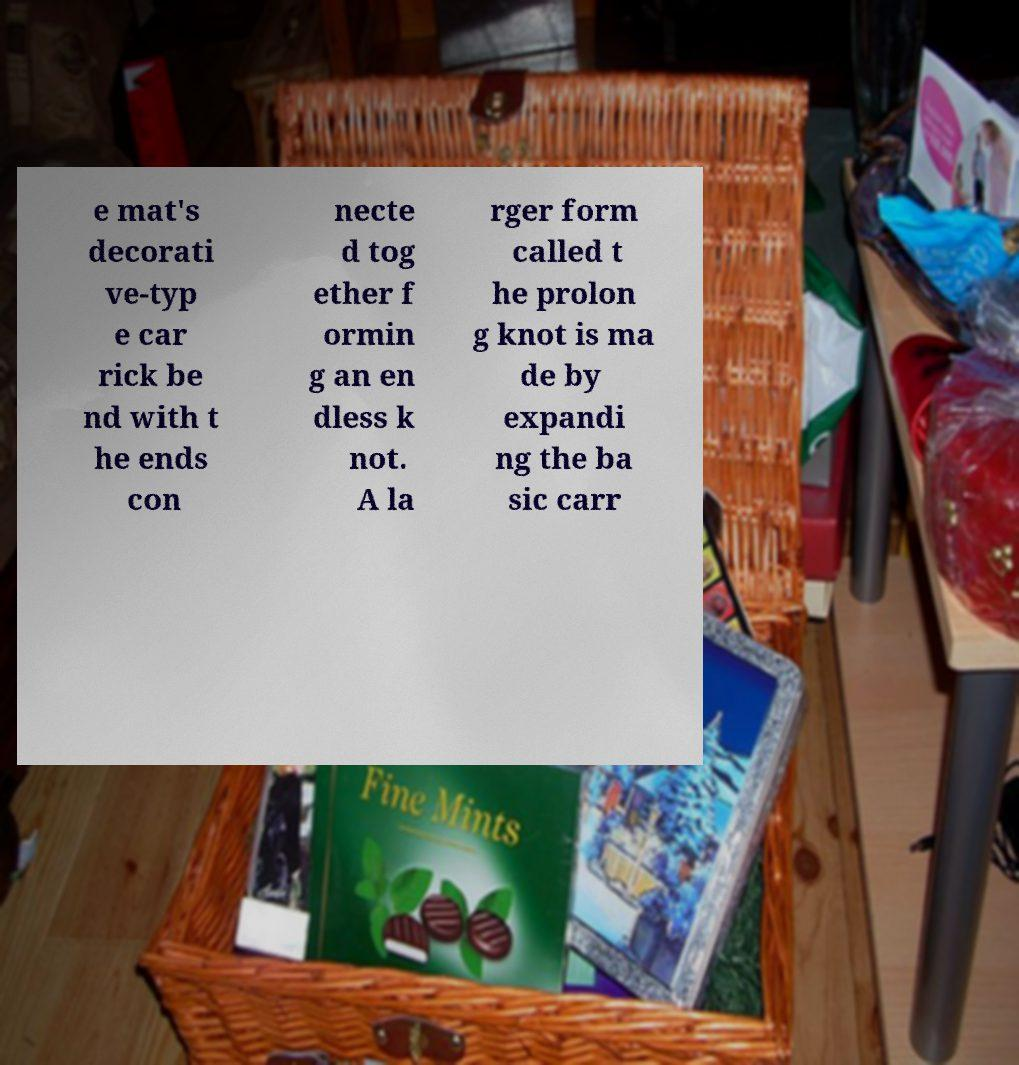I need the written content from this picture converted into text. Can you do that? e mat's decorati ve-typ e car rick be nd with t he ends con necte d tog ether f ormin g an en dless k not. A la rger form called t he prolon g knot is ma de by expandi ng the ba sic carr 